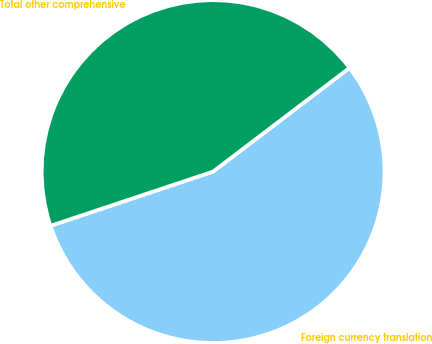<chart> <loc_0><loc_0><loc_500><loc_500><pie_chart><fcel>Foreign currency translation<fcel>Total other comprehensive<nl><fcel>55.22%<fcel>44.78%<nl></chart> 